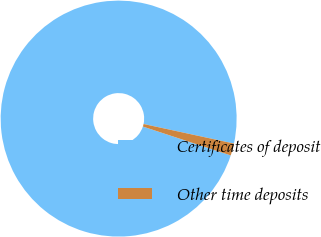Convert chart to OTSL. <chart><loc_0><loc_0><loc_500><loc_500><pie_chart><fcel>Certificates of deposit<fcel>Other time deposits<nl><fcel>98.34%<fcel>1.66%<nl></chart> 